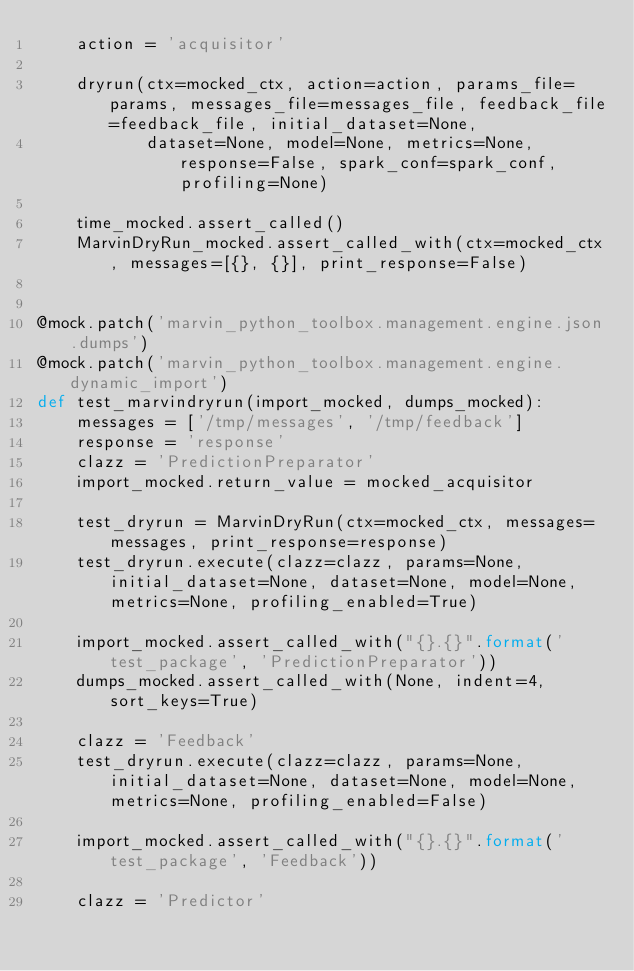<code> <loc_0><loc_0><loc_500><loc_500><_Python_>    action = 'acquisitor'

    dryrun(ctx=mocked_ctx, action=action, params_file=params, messages_file=messages_file, feedback_file=feedback_file, initial_dataset=None,
           dataset=None, model=None, metrics=None, response=False, spark_conf=spark_conf, profiling=None)

    time_mocked.assert_called()
    MarvinDryRun_mocked.assert_called_with(ctx=mocked_ctx, messages=[{}, {}], print_response=False)


@mock.patch('marvin_python_toolbox.management.engine.json.dumps')
@mock.patch('marvin_python_toolbox.management.engine.dynamic_import')
def test_marvindryrun(import_mocked, dumps_mocked):
    messages = ['/tmp/messages', '/tmp/feedback']
    response = 'response'
    clazz = 'PredictionPreparator'
    import_mocked.return_value = mocked_acquisitor

    test_dryrun = MarvinDryRun(ctx=mocked_ctx, messages=messages, print_response=response)
    test_dryrun.execute(clazz=clazz, params=None, initial_dataset=None, dataset=None, model=None, metrics=None, profiling_enabled=True)

    import_mocked.assert_called_with("{}.{}".format('test_package', 'PredictionPreparator'))
    dumps_mocked.assert_called_with(None, indent=4, sort_keys=True)

    clazz = 'Feedback'
    test_dryrun.execute(clazz=clazz, params=None, initial_dataset=None, dataset=None, model=None, metrics=None, profiling_enabled=False)

    import_mocked.assert_called_with("{}.{}".format('test_package', 'Feedback'))

    clazz = 'Predictor'</code> 